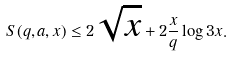<formula> <loc_0><loc_0><loc_500><loc_500>S ( q , a , x ) \leq 2 \sqrt { x } + 2 \frac { x } { q } \log 3 x .</formula> 